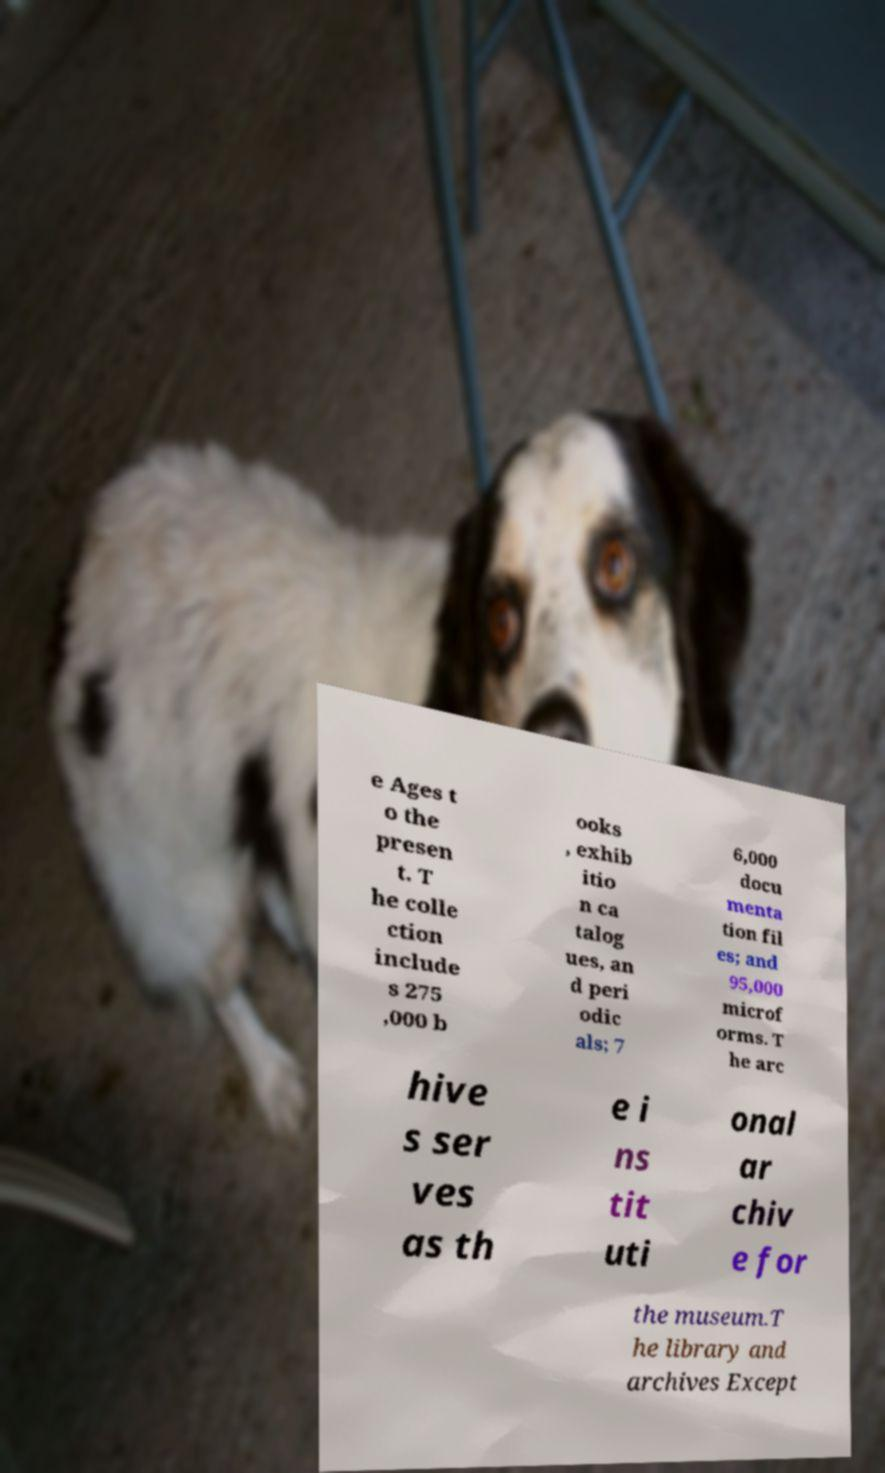For documentation purposes, I need the text within this image transcribed. Could you provide that? e Ages t o the presen t. T he colle ction include s 275 ,000 b ooks , exhib itio n ca talog ues, an d peri odic als; 7 6,000 docu menta tion fil es; and 95,000 microf orms. T he arc hive s ser ves as th e i ns tit uti onal ar chiv e for the museum.T he library and archives Except 